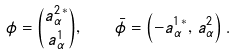<formula> <loc_0><loc_0><loc_500><loc_500>\phi = { a _ { \alpha } ^ { 2 \, * } \choose a ^ { 1 } _ { \alpha } } , \quad \bar { \phi } = \left ( - a _ { \alpha } ^ { 1 \, * } , \, a ^ { 2 } _ { \alpha } \right ) .</formula> 